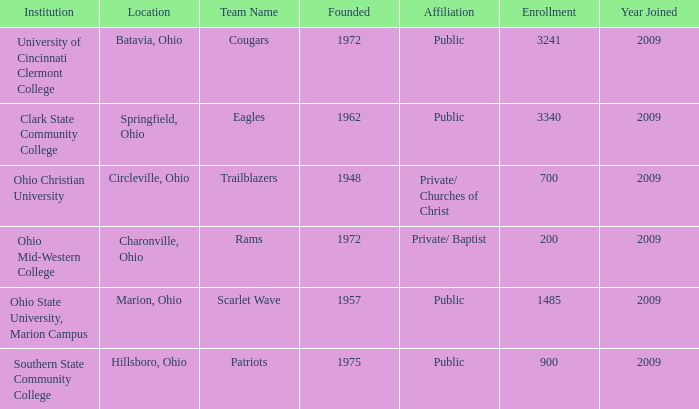How many entries are there for founded when the location was springfield, ohio? 1.0. 